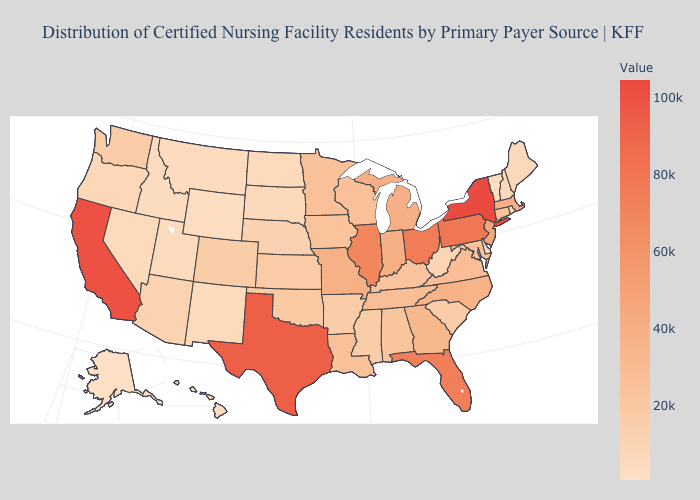Does South Dakota have the highest value in the MidWest?
Concise answer only. No. Which states have the lowest value in the West?
Be succinct. Alaska. Does the map have missing data?
Be succinct. No. Which states have the highest value in the USA?
Give a very brief answer. New York. Which states hav the highest value in the Northeast?
Quick response, please. New York. Does Kentucky have a lower value than Hawaii?
Be succinct. No. Which states have the highest value in the USA?
Keep it brief. New York. 